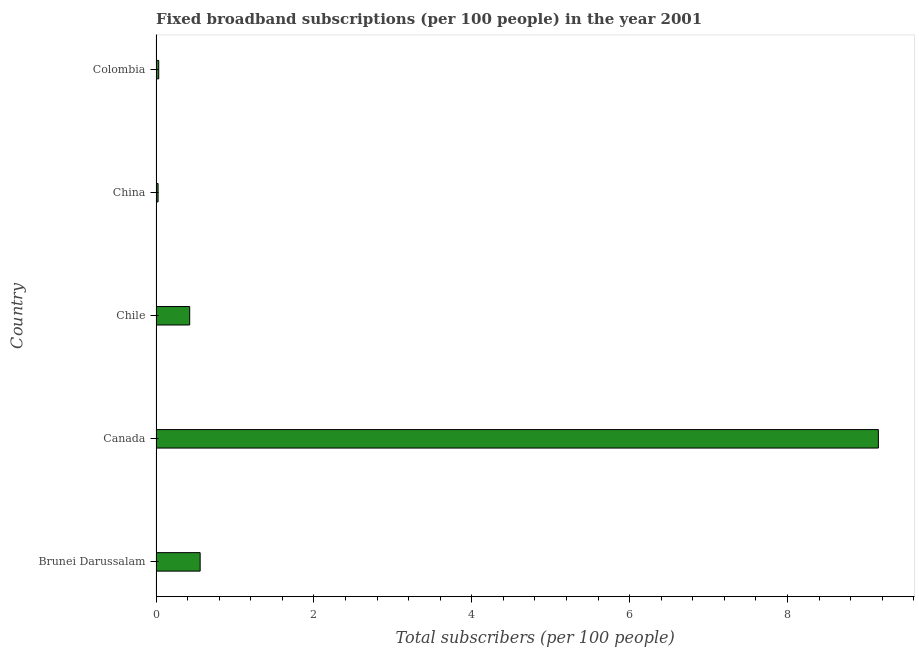Does the graph contain grids?
Your response must be concise. No. What is the title of the graph?
Your answer should be very brief. Fixed broadband subscriptions (per 100 people) in the year 2001. What is the label or title of the X-axis?
Provide a short and direct response. Total subscribers (per 100 people). What is the total number of fixed broadband subscriptions in Canada?
Offer a very short reply. 9.15. Across all countries, what is the maximum total number of fixed broadband subscriptions?
Provide a succinct answer. 9.15. Across all countries, what is the minimum total number of fixed broadband subscriptions?
Your answer should be compact. 0.03. In which country was the total number of fixed broadband subscriptions minimum?
Your response must be concise. China. What is the sum of the total number of fixed broadband subscriptions?
Give a very brief answer. 10.2. What is the difference between the total number of fixed broadband subscriptions in Brunei Darussalam and Chile?
Offer a very short reply. 0.13. What is the average total number of fixed broadband subscriptions per country?
Offer a very short reply. 2.04. What is the median total number of fixed broadband subscriptions?
Your answer should be very brief. 0.43. What is the ratio of the total number of fixed broadband subscriptions in Brunei Darussalam to that in Colombia?
Your response must be concise. 16.4. Is the total number of fixed broadband subscriptions in Canada less than that in China?
Your answer should be very brief. No. Is the difference between the total number of fixed broadband subscriptions in Brunei Darussalam and Chile greater than the difference between any two countries?
Ensure brevity in your answer.  No. What is the difference between the highest and the second highest total number of fixed broadband subscriptions?
Your response must be concise. 8.59. What is the difference between the highest and the lowest total number of fixed broadband subscriptions?
Provide a short and direct response. 9.13. How many bars are there?
Keep it short and to the point. 5. What is the Total subscribers (per 100 people) of Brunei Darussalam?
Your answer should be compact. 0.56. What is the Total subscribers (per 100 people) in Canada?
Keep it short and to the point. 9.15. What is the Total subscribers (per 100 people) of Chile?
Provide a succinct answer. 0.43. What is the Total subscribers (per 100 people) in China?
Make the answer very short. 0.03. What is the Total subscribers (per 100 people) of Colombia?
Offer a very short reply. 0.03. What is the difference between the Total subscribers (per 100 people) in Brunei Darussalam and Canada?
Provide a short and direct response. -8.59. What is the difference between the Total subscribers (per 100 people) in Brunei Darussalam and Chile?
Provide a short and direct response. 0.13. What is the difference between the Total subscribers (per 100 people) in Brunei Darussalam and China?
Give a very brief answer. 0.53. What is the difference between the Total subscribers (per 100 people) in Brunei Darussalam and Colombia?
Give a very brief answer. 0.53. What is the difference between the Total subscribers (per 100 people) in Canada and Chile?
Offer a very short reply. 8.73. What is the difference between the Total subscribers (per 100 people) in Canada and China?
Your answer should be very brief. 9.13. What is the difference between the Total subscribers (per 100 people) in Canada and Colombia?
Make the answer very short. 9.12. What is the difference between the Total subscribers (per 100 people) in Chile and China?
Make the answer very short. 0.4. What is the difference between the Total subscribers (per 100 people) in Chile and Colombia?
Give a very brief answer. 0.39. What is the difference between the Total subscribers (per 100 people) in China and Colombia?
Make the answer very short. -0.01. What is the ratio of the Total subscribers (per 100 people) in Brunei Darussalam to that in Canada?
Provide a succinct answer. 0.06. What is the ratio of the Total subscribers (per 100 people) in Brunei Darussalam to that in Chile?
Provide a short and direct response. 1.31. What is the ratio of the Total subscribers (per 100 people) in Brunei Darussalam to that in China?
Your response must be concise. 21.41. What is the ratio of the Total subscribers (per 100 people) in Brunei Darussalam to that in Colombia?
Offer a very short reply. 16.4. What is the ratio of the Total subscribers (per 100 people) in Canada to that in Chile?
Ensure brevity in your answer.  21.45. What is the ratio of the Total subscribers (per 100 people) in Canada to that in China?
Provide a succinct answer. 350.52. What is the ratio of the Total subscribers (per 100 people) in Canada to that in Colombia?
Offer a terse response. 268.4. What is the ratio of the Total subscribers (per 100 people) in Chile to that in China?
Your response must be concise. 16.34. What is the ratio of the Total subscribers (per 100 people) in Chile to that in Colombia?
Your answer should be very brief. 12.51. What is the ratio of the Total subscribers (per 100 people) in China to that in Colombia?
Your answer should be compact. 0.77. 